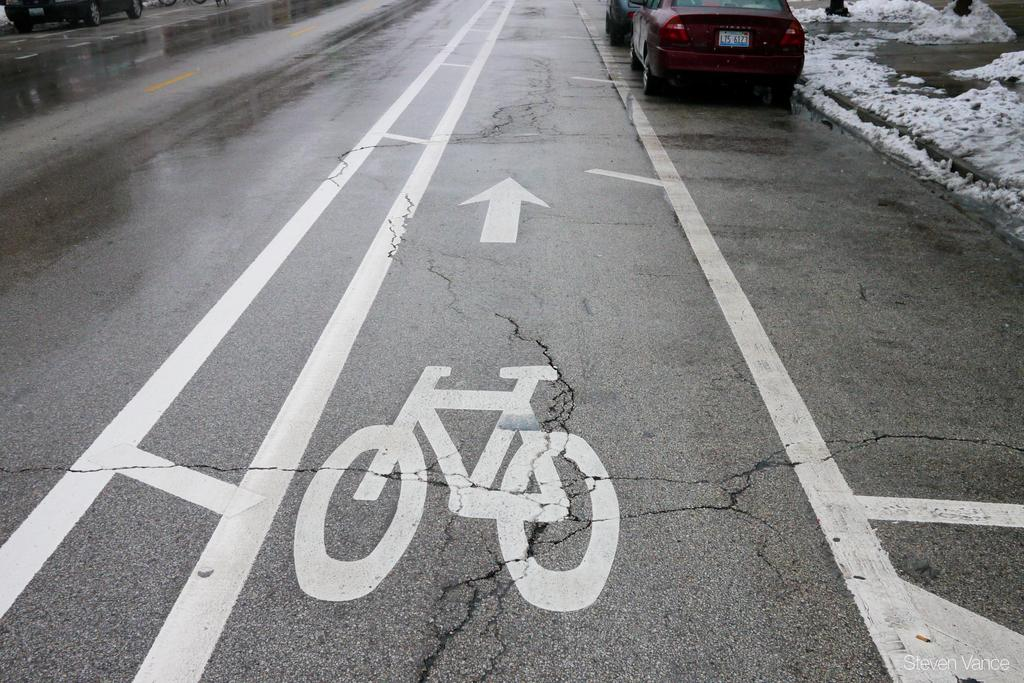What can be seen on the road in the image? There are vehicles on the road in the image. What is present on the footpath in the image? There is a heap of snow on the footpath in the image. What time is the meeting scheduled for in the image? There is no indication of a meeting or any time-related information in the image. 